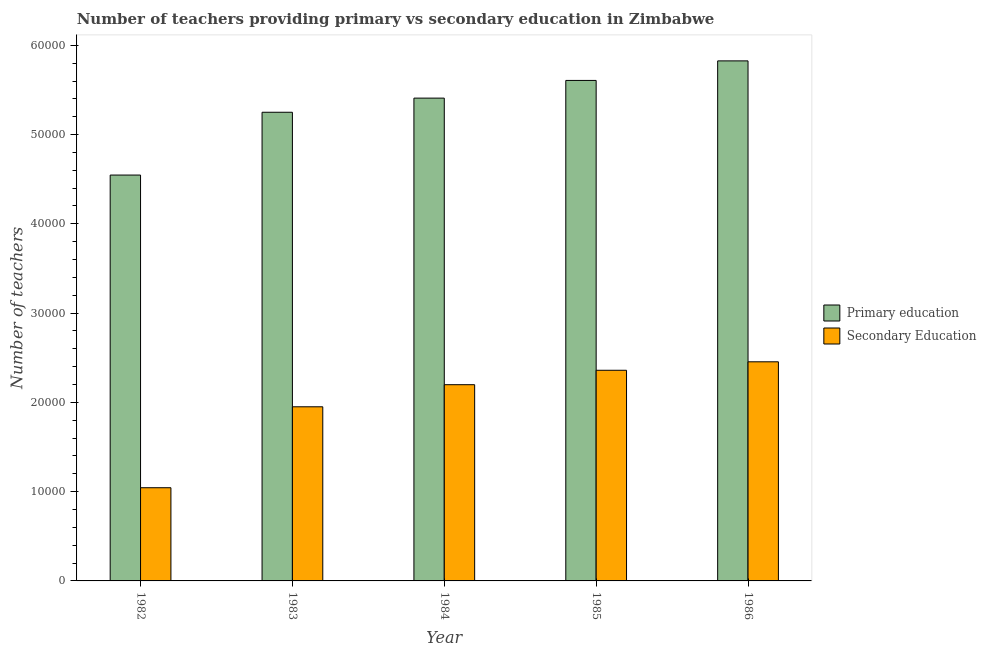How many different coloured bars are there?
Offer a very short reply. 2. How many groups of bars are there?
Your answer should be very brief. 5. Are the number of bars per tick equal to the number of legend labels?
Keep it short and to the point. Yes. How many bars are there on the 5th tick from the right?
Provide a short and direct response. 2. In how many cases, is the number of bars for a given year not equal to the number of legend labels?
Provide a succinct answer. 0. What is the number of secondary teachers in 1984?
Keep it short and to the point. 2.20e+04. Across all years, what is the maximum number of primary teachers?
Your answer should be very brief. 5.83e+04. Across all years, what is the minimum number of primary teachers?
Your answer should be very brief. 4.55e+04. What is the total number of primary teachers in the graph?
Keep it short and to the point. 2.66e+05. What is the difference between the number of primary teachers in 1982 and that in 1983?
Provide a short and direct response. -7035. What is the difference between the number of primary teachers in 1984 and the number of secondary teachers in 1985?
Your answer should be very brief. -1981. What is the average number of secondary teachers per year?
Provide a short and direct response. 2.00e+04. In how many years, is the number of primary teachers greater than 10000?
Offer a terse response. 5. What is the ratio of the number of secondary teachers in 1982 to that in 1986?
Your answer should be very brief. 0.43. Is the difference between the number of primary teachers in 1985 and 1986 greater than the difference between the number of secondary teachers in 1985 and 1986?
Keep it short and to the point. No. What is the difference between the highest and the second highest number of secondary teachers?
Keep it short and to the point. 949. What is the difference between the highest and the lowest number of secondary teachers?
Give a very brief answer. 1.41e+04. In how many years, is the number of secondary teachers greater than the average number of secondary teachers taken over all years?
Provide a succinct answer. 3. Is the sum of the number of primary teachers in 1985 and 1986 greater than the maximum number of secondary teachers across all years?
Give a very brief answer. Yes. What does the 2nd bar from the left in 1983 represents?
Ensure brevity in your answer.  Secondary Education. What does the 1st bar from the right in 1985 represents?
Offer a very short reply. Secondary Education. Are all the bars in the graph horizontal?
Keep it short and to the point. No. Are the values on the major ticks of Y-axis written in scientific E-notation?
Keep it short and to the point. No. Does the graph contain any zero values?
Your response must be concise. No. Where does the legend appear in the graph?
Your answer should be compact. Center right. How are the legend labels stacked?
Ensure brevity in your answer.  Vertical. What is the title of the graph?
Your answer should be very brief. Number of teachers providing primary vs secondary education in Zimbabwe. What is the label or title of the Y-axis?
Your response must be concise. Number of teachers. What is the Number of teachers in Primary education in 1982?
Your answer should be very brief. 4.55e+04. What is the Number of teachers of Secondary Education in 1982?
Ensure brevity in your answer.  1.04e+04. What is the Number of teachers in Primary education in 1983?
Ensure brevity in your answer.  5.25e+04. What is the Number of teachers of Secondary Education in 1983?
Your answer should be very brief. 1.95e+04. What is the Number of teachers in Primary education in 1984?
Offer a very short reply. 5.41e+04. What is the Number of teachers in Secondary Education in 1984?
Make the answer very short. 2.20e+04. What is the Number of teachers of Primary education in 1985?
Provide a short and direct response. 5.61e+04. What is the Number of teachers of Secondary Education in 1985?
Your response must be concise. 2.36e+04. What is the Number of teachers of Primary education in 1986?
Your response must be concise. 5.83e+04. What is the Number of teachers in Secondary Education in 1986?
Provide a succinct answer. 2.45e+04. Across all years, what is the maximum Number of teachers of Primary education?
Keep it short and to the point. 5.83e+04. Across all years, what is the maximum Number of teachers of Secondary Education?
Offer a very short reply. 2.45e+04. Across all years, what is the minimum Number of teachers in Primary education?
Provide a short and direct response. 4.55e+04. Across all years, what is the minimum Number of teachers of Secondary Education?
Your answer should be very brief. 1.04e+04. What is the total Number of teachers in Primary education in the graph?
Give a very brief answer. 2.66e+05. What is the total Number of teachers of Secondary Education in the graph?
Ensure brevity in your answer.  1.00e+05. What is the difference between the Number of teachers of Primary education in 1982 and that in 1983?
Your response must be concise. -7035. What is the difference between the Number of teachers of Secondary Education in 1982 and that in 1983?
Your answer should be very brief. -9067. What is the difference between the Number of teachers of Primary education in 1982 and that in 1984?
Your answer should be very brief. -8619. What is the difference between the Number of teachers in Secondary Education in 1982 and that in 1984?
Your response must be concise. -1.15e+04. What is the difference between the Number of teachers of Primary education in 1982 and that in 1985?
Provide a short and direct response. -1.06e+04. What is the difference between the Number of teachers in Secondary Education in 1982 and that in 1985?
Your response must be concise. -1.32e+04. What is the difference between the Number of teachers in Primary education in 1982 and that in 1986?
Your answer should be compact. -1.28e+04. What is the difference between the Number of teachers of Secondary Education in 1982 and that in 1986?
Keep it short and to the point. -1.41e+04. What is the difference between the Number of teachers in Primary education in 1983 and that in 1984?
Provide a short and direct response. -1584. What is the difference between the Number of teachers of Secondary Education in 1983 and that in 1984?
Offer a terse response. -2474. What is the difference between the Number of teachers in Primary education in 1983 and that in 1985?
Offer a very short reply. -3565. What is the difference between the Number of teachers in Secondary Education in 1983 and that in 1985?
Provide a short and direct response. -4091. What is the difference between the Number of teachers in Primary education in 1983 and that in 1986?
Ensure brevity in your answer.  -5755. What is the difference between the Number of teachers of Secondary Education in 1983 and that in 1986?
Your answer should be very brief. -5040. What is the difference between the Number of teachers in Primary education in 1984 and that in 1985?
Your response must be concise. -1981. What is the difference between the Number of teachers of Secondary Education in 1984 and that in 1985?
Offer a very short reply. -1617. What is the difference between the Number of teachers of Primary education in 1984 and that in 1986?
Give a very brief answer. -4171. What is the difference between the Number of teachers in Secondary Education in 1984 and that in 1986?
Provide a succinct answer. -2566. What is the difference between the Number of teachers in Primary education in 1985 and that in 1986?
Keep it short and to the point. -2190. What is the difference between the Number of teachers in Secondary Education in 1985 and that in 1986?
Provide a short and direct response. -949. What is the difference between the Number of teachers in Primary education in 1982 and the Number of teachers in Secondary Education in 1983?
Provide a short and direct response. 2.60e+04. What is the difference between the Number of teachers in Primary education in 1982 and the Number of teachers in Secondary Education in 1984?
Provide a succinct answer. 2.35e+04. What is the difference between the Number of teachers of Primary education in 1982 and the Number of teachers of Secondary Education in 1985?
Your answer should be compact. 2.19e+04. What is the difference between the Number of teachers of Primary education in 1982 and the Number of teachers of Secondary Education in 1986?
Keep it short and to the point. 2.09e+04. What is the difference between the Number of teachers of Primary education in 1983 and the Number of teachers of Secondary Education in 1984?
Offer a very short reply. 3.05e+04. What is the difference between the Number of teachers in Primary education in 1983 and the Number of teachers in Secondary Education in 1985?
Provide a succinct answer. 2.89e+04. What is the difference between the Number of teachers of Primary education in 1983 and the Number of teachers of Secondary Education in 1986?
Provide a short and direct response. 2.80e+04. What is the difference between the Number of teachers in Primary education in 1984 and the Number of teachers in Secondary Education in 1985?
Your answer should be compact. 3.05e+04. What is the difference between the Number of teachers in Primary education in 1984 and the Number of teachers in Secondary Education in 1986?
Offer a very short reply. 2.95e+04. What is the difference between the Number of teachers in Primary education in 1985 and the Number of teachers in Secondary Education in 1986?
Ensure brevity in your answer.  3.15e+04. What is the average Number of teachers in Primary education per year?
Offer a very short reply. 5.33e+04. What is the average Number of teachers in Secondary Education per year?
Offer a terse response. 2.00e+04. In the year 1982, what is the difference between the Number of teachers in Primary education and Number of teachers in Secondary Education?
Your answer should be very brief. 3.50e+04. In the year 1983, what is the difference between the Number of teachers of Primary education and Number of teachers of Secondary Education?
Offer a very short reply. 3.30e+04. In the year 1984, what is the difference between the Number of teachers of Primary education and Number of teachers of Secondary Education?
Make the answer very short. 3.21e+04. In the year 1985, what is the difference between the Number of teachers in Primary education and Number of teachers in Secondary Education?
Ensure brevity in your answer.  3.25e+04. In the year 1986, what is the difference between the Number of teachers of Primary education and Number of teachers of Secondary Education?
Offer a terse response. 3.37e+04. What is the ratio of the Number of teachers of Primary education in 1982 to that in 1983?
Make the answer very short. 0.87. What is the ratio of the Number of teachers in Secondary Education in 1982 to that in 1983?
Give a very brief answer. 0.54. What is the ratio of the Number of teachers in Primary education in 1982 to that in 1984?
Offer a very short reply. 0.84. What is the ratio of the Number of teachers of Secondary Education in 1982 to that in 1984?
Make the answer very short. 0.47. What is the ratio of the Number of teachers in Primary education in 1982 to that in 1985?
Provide a short and direct response. 0.81. What is the ratio of the Number of teachers of Secondary Education in 1982 to that in 1985?
Provide a short and direct response. 0.44. What is the ratio of the Number of teachers in Primary education in 1982 to that in 1986?
Provide a succinct answer. 0.78. What is the ratio of the Number of teachers in Secondary Education in 1982 to that in 1986?
Make the answer very short. 0.43. What is the ratio of the Number of teachers of Primary education in 1983 to that in 1984?
Make the answer very short. 0.97. What is the ratio of the Number of teachers in Secondary Education in 1983 to that in 1984?
Keep it short and to the point. 0.89. What is the ratio of the Number of teachers of Primary education in 1983 to that in 1985?
Your answer should be compact. 0.94. What is the ratio of the Number of teachers in Secondary Education in 1983 to that in 1985?
Provide a succinct answer. 0.83. What is the ratio of the Number of teachers in Primary education in 1983 to that in 1986?
Your answer should be very brief. 0.9. What is the ratio of the Number of teachers in Secondary Education in 1983 to that in 1986?
Keep it short and to the point. 0.79. What is the ratio of the Number of teachers of Primary education in 1984 to that in 1985?
Provide a short and direct response. 0.96. What is the ratio of the Number of teachers of Secondary Education in 1984 to that in 1985?
Your answer should be compact. 0.93. What is the ratio of the Number of teachers of Primary education in 1984 to that in 1986?
Offer a very short reply. 0.93. What is the ratio of the Number of teachers in Secondary Education in 1984 to that in 1986?
Provide a short and direct response. 0.9. What is the ratio of the Number of teachers of Primary education in 1985 to that in 1986?
Give a very brief answer. 0.96. What is the ratio of the Number of teachers of Secondary Education in 1985 to that in 1986?
Your answer should be very brief. 0.96. What is the difference between the highest and the second highest Number of teachers of Primary education?
Your answer should be very brief. 2190. What is the difference between the highest and the second highest Number of teachers in Secondary Education?
Provide a short and direct response. 949. What is the difference between the highest and the lowest Number of teachers in Primary education?
Keep it short and to the point. 1.28e+04. What is the difference between the highest and the lowest Number of teachers of Secondary Education?
Give a very brief answer. 1.41e+04. 